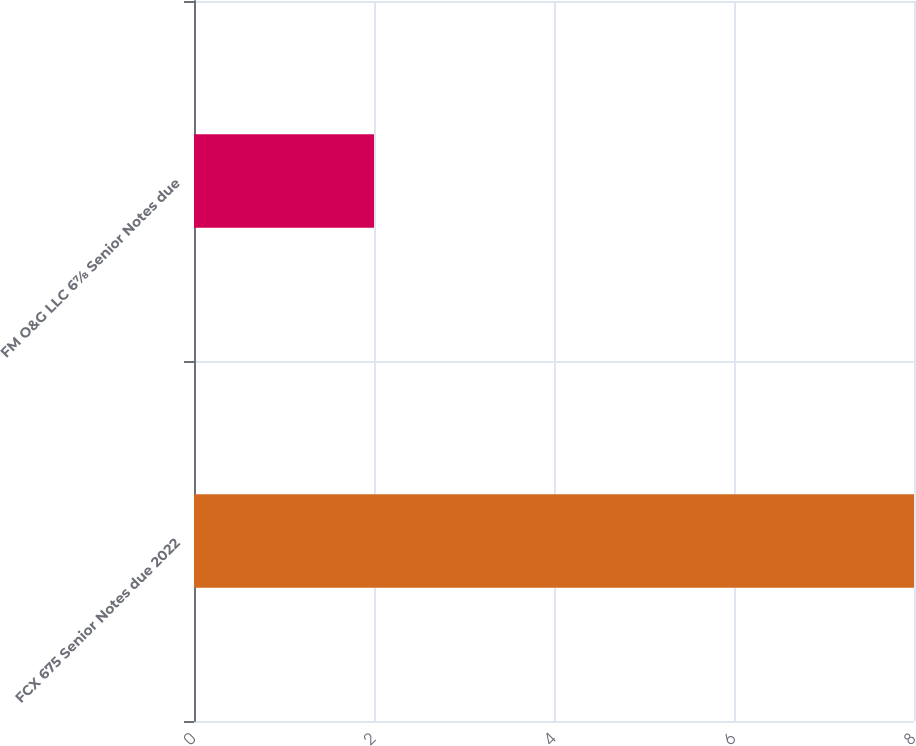Convert chart. <chart><loc_0><loc_0><loc_500><loc_500><bar_chart><fcel>FCX 675 Senior Notes due 2022<fcel>FM O&G LLC 6⅞ Senior Notes due<nl><fcel>8<fcel>2<nl></chart> 